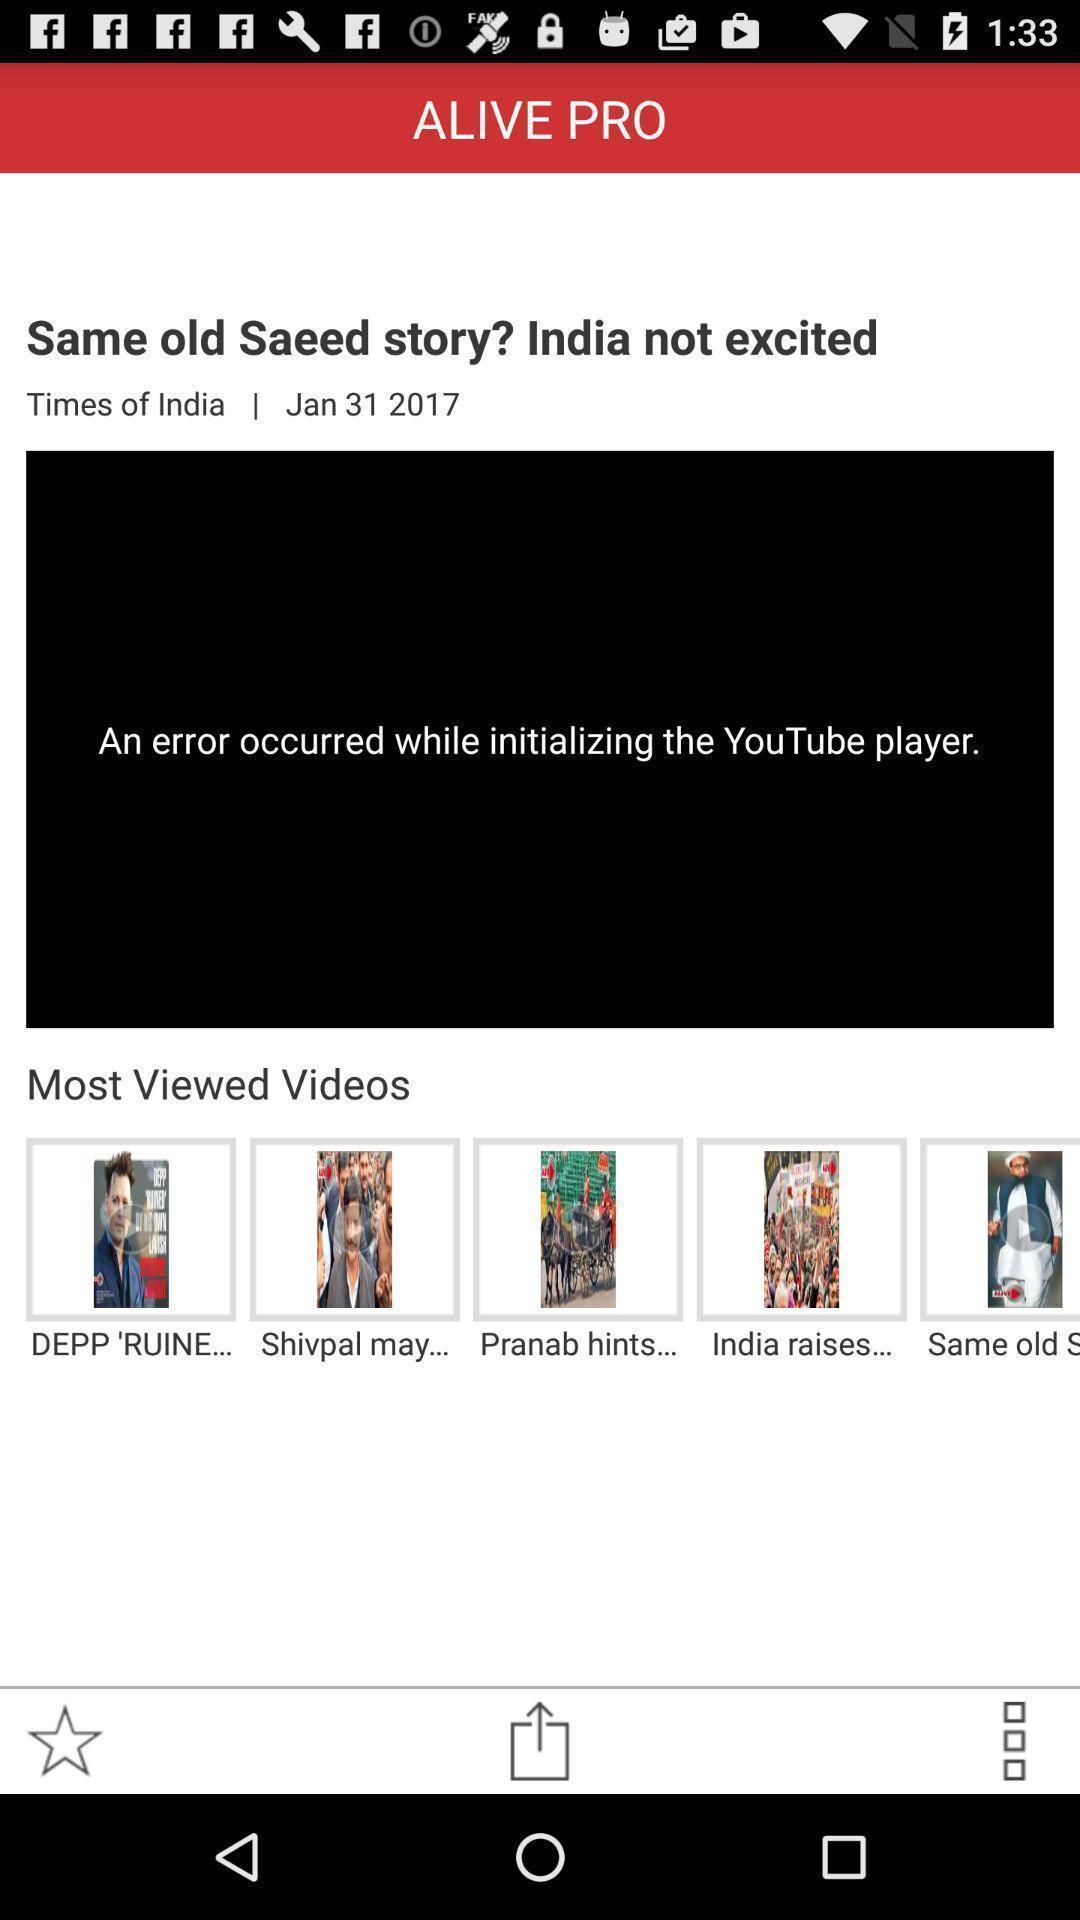Explain what's happening in this screen capture. Web page shows error in instalizing the player. 